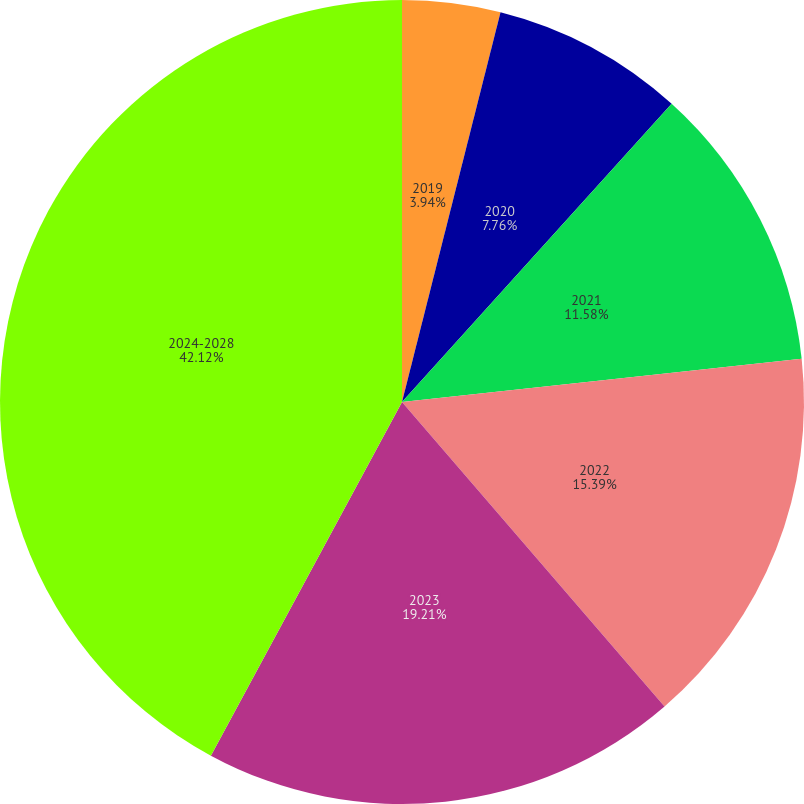Convert chart to OTSL. <chart><loc_0><loc_0><loc_500><loc_500><pie_chart><fcel>2019<fcel>2020<fcel>2021<fcel>2022<fcel>2023<fcel>2024-2028<nl><fcel>3.94%<fcel>7.76%<fcel>11.58%<fcel>15.39%<fcel>19.21%<fcel>42.11%<nl></chart> 